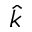<formula> <loc_0><loc_0><loc_500><loc_500>\hat { k }</formula> 